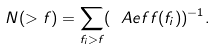<formula> <loc_0><loc_0><loc_500><loc_500>N ( > f ) = \sum _ { f _ { i } > f } ( \ A e f f ( f _ { i } ) ) ^ { - 1 } .</formula> 